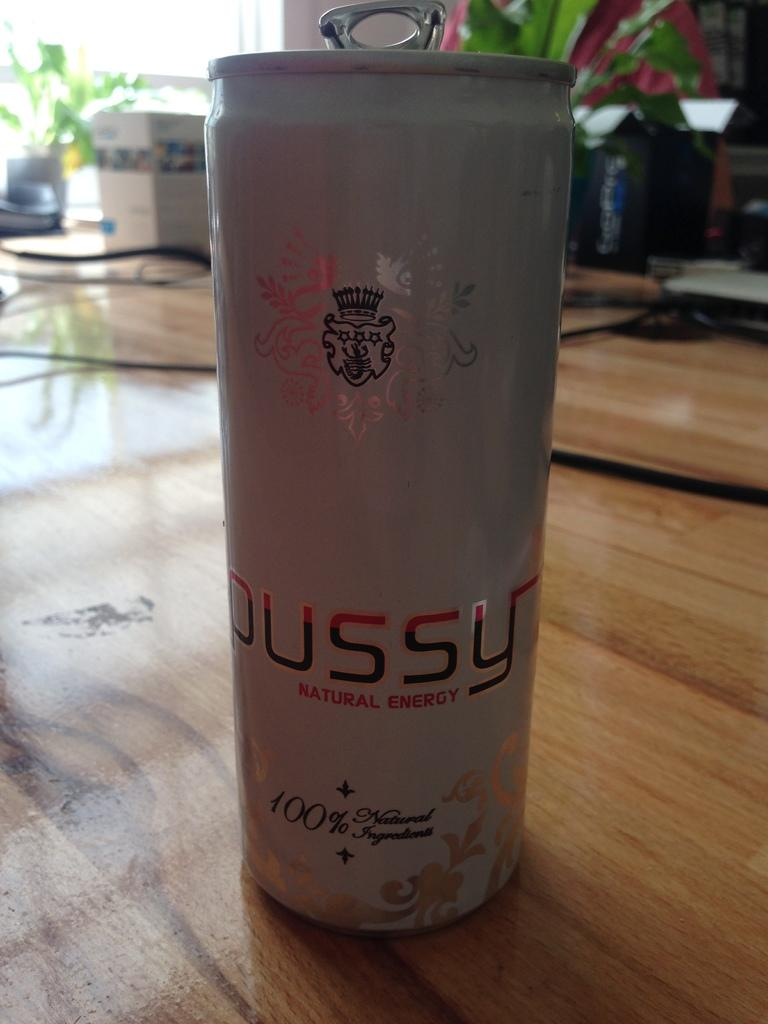What is located in the middle of the image? There is a tin in the middle of the image. What can be seen in the background of the image? There are plants in the background of the image. How many sheep can be seen in the image? There are no sheep present in the image. What type of net is visible in the image? There is no net present in the image. 